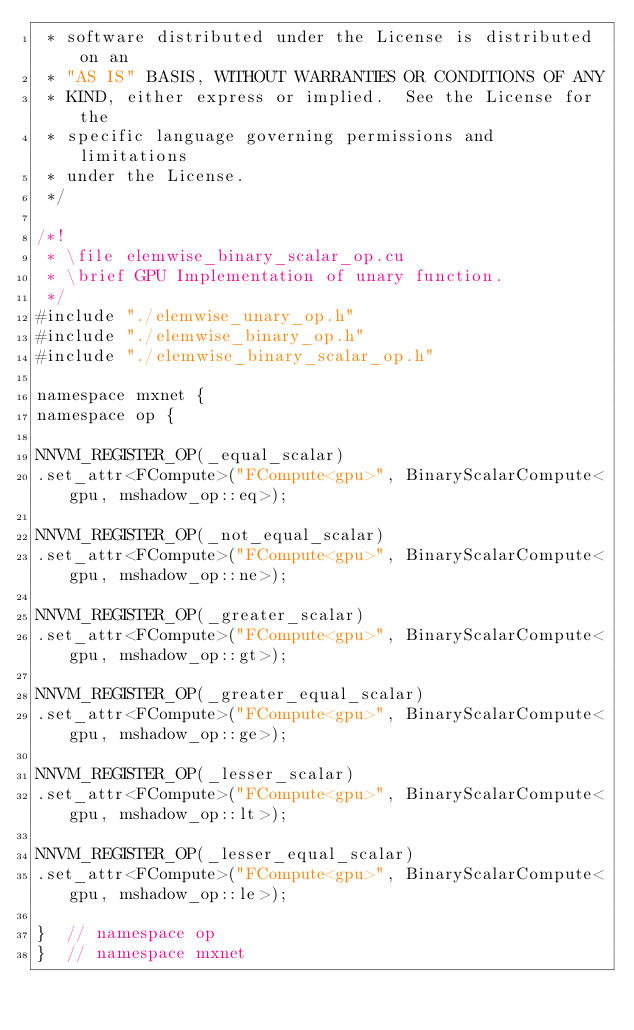Convert code to text. <code><loc_0><loc_0><loc_500><loc_500><_Cuda_> * software distributed under the License is distributed on an
 * "AS IS" BASIS, WITHOUT WARRANTIES OR CONDITIONS OF ANY
 * KIND, either express or implied.  See the License for the
 * specific language governing permissions and limitations
 * under the License.
 */

/*!
 * \file elemwise_binary_scalar_op.cu
 * \brief GPU Implementation of unary function.
 */
#include "./elemwise_unary_op.h"
#include "./elemwise_binary_op.h"
#include "./elemwise_binary_scalar_op.h"

namespace mxnet {
namespace op {

NNVM_REGISTER_OP(_equal_scalar)
.set_attr<FCompute>("FCompute<gpu>", BinaryScalarCompute<gpu, mshadow_op::eq>);

NNVM_REGISTER_OP(_not_equal_scalar)
.set_attr<FCompute>("FCompute<gpu>", BinaryScalarCompute<gpu, mshadow_op::ne>);

NNVM_REGISTER_OP(_greater_scalar)
.set_attr<FCompute>("FCompute<gpu>", BinaryScalarCompute<gpu, mshadow_op::gt>);

NNVM_REGISTER_OP(_greater_equal_scalar)
.set_attr<FCompute>("FCompute<gpu>", BinaryScalarCompute<gpu, mshadow_op::ge>);

NNVM_REGISTER_OP(_lesser_scalar)
.set_attr<FCompute>("FCompute<gpu>", BinaryScalarCompute<gpu, mshadow_op::lt>);

NNVM_REGISTER_OP(_lesser_equal_scalar)
.set_attr<FCompute>("FCompute<gpu>", BinaryScalarCompute<gpu, mshadow_op::le>);

}  // namespace op
}  // namespace mxnet
</code> 